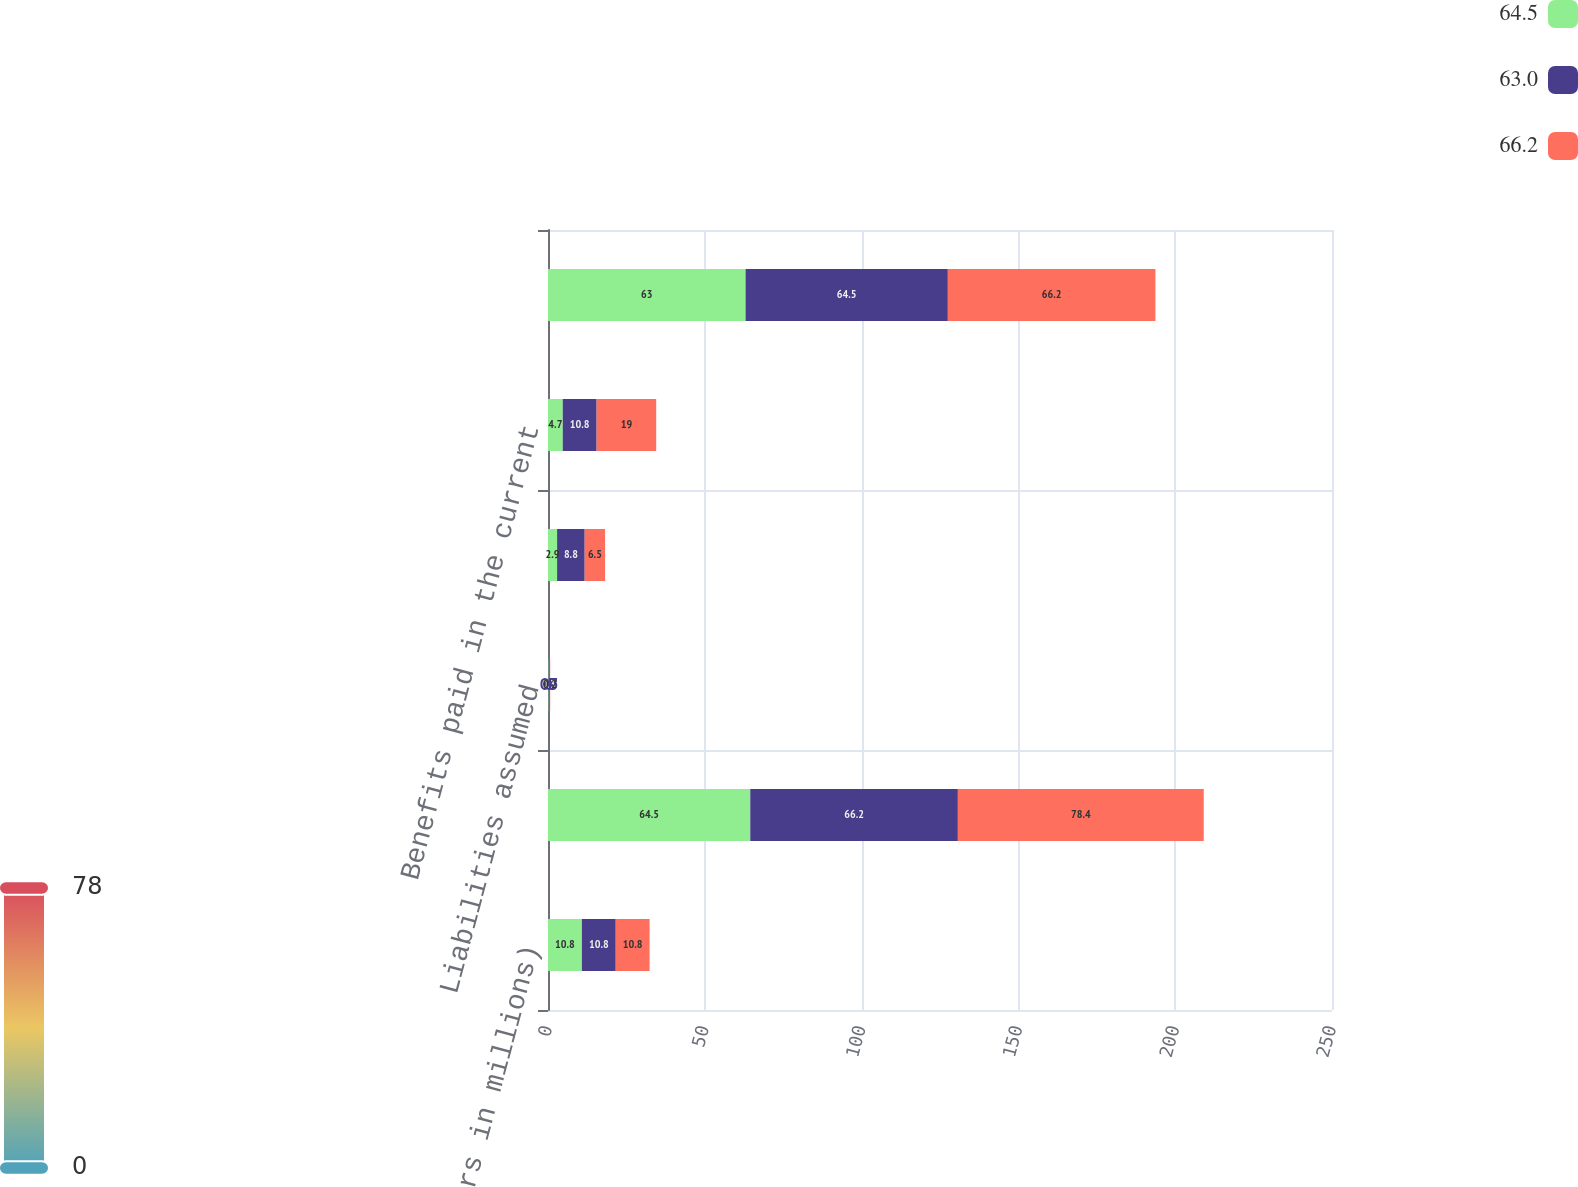Convert chart. <chart><loc_0><loc_0><loc_500><loc_500><stacked_bar_chart><ecel><fcel>(Dollars in millions)<fcel>Balance at beginning of year<fcel>Liabilities assumed<fcel>Adjustments to reserves<fcel>Benefits paid in the current<fcel>Balance at end of year<nl><fcel>64.5<fcel>10.8<fcel>64.5<fcel>0.2<fcel>2.9<fcel>4.7<fcel>63<nl><fcel>63<fcel>10.8<fcel>66.2<fcel>0.3<fcel>8.8<fcel>10.8<fcel>64.5<nl><fcel>66.2<fcel>10.8<fcel>78.4<fcel>0.2<fcel>6.5<fcel>19<fcel>66.2<nl></chart> 